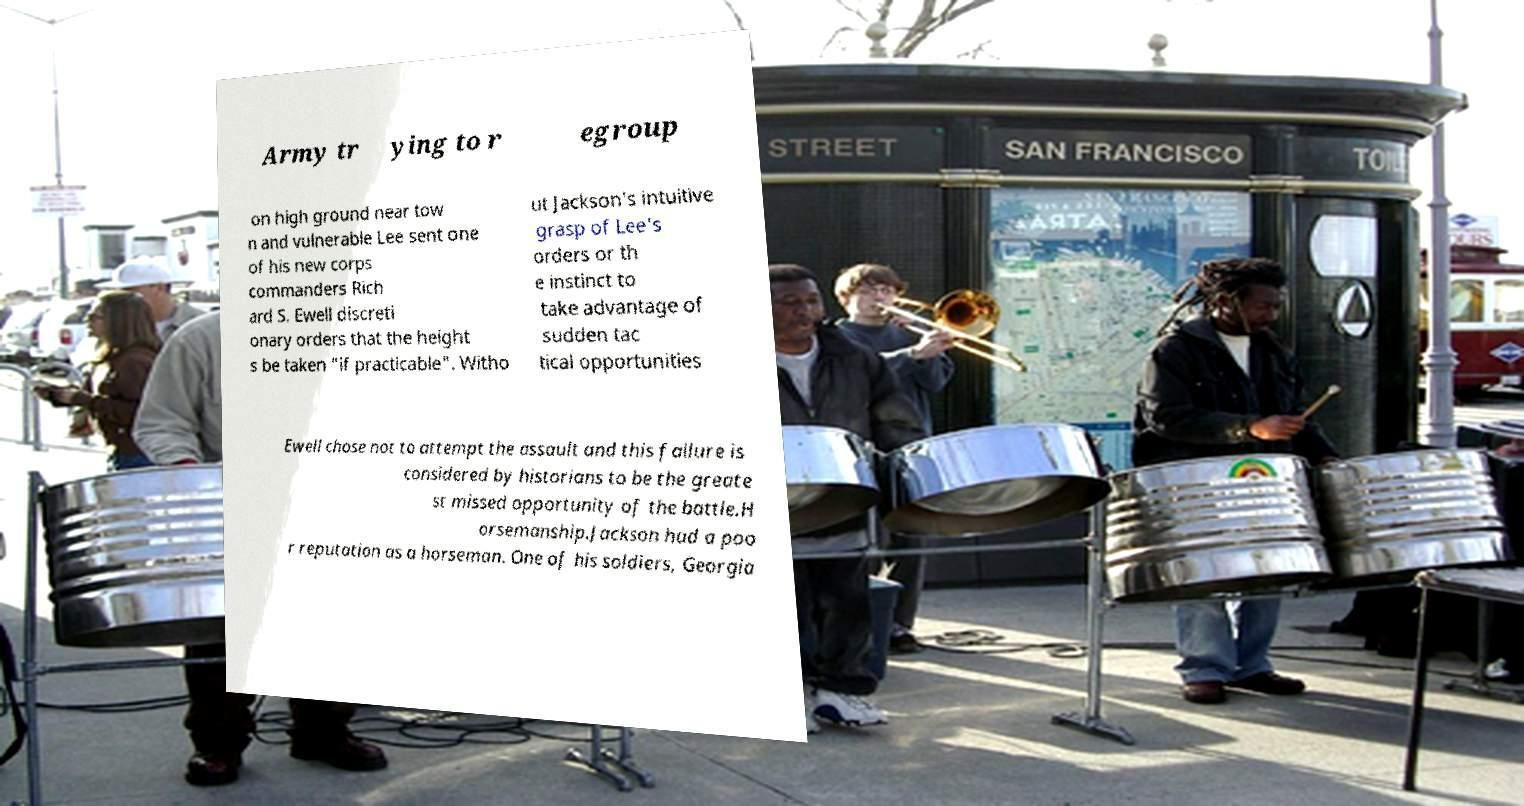There's text embedded in this image that I need extracted. Can you transcribe it verbatim? Army tr ying to r egroup on high ground near tow n and vulnerable Lee sent one of his new corps commanders Rich ard S. Ewell discreti onary orders that the height s be taken "if practicable". Witho ut Jackson's intuitive grasp of Lee's orders or th e instinct to take advantage of sudden tac tical opportunities Ewell chose not to attempt the assault and this failure is considered by historians to be the greate st missed opportunity of the battle.H orsemanship.Jackson had a poo r reputation as a horseman. One of his soldiers, Georgia 